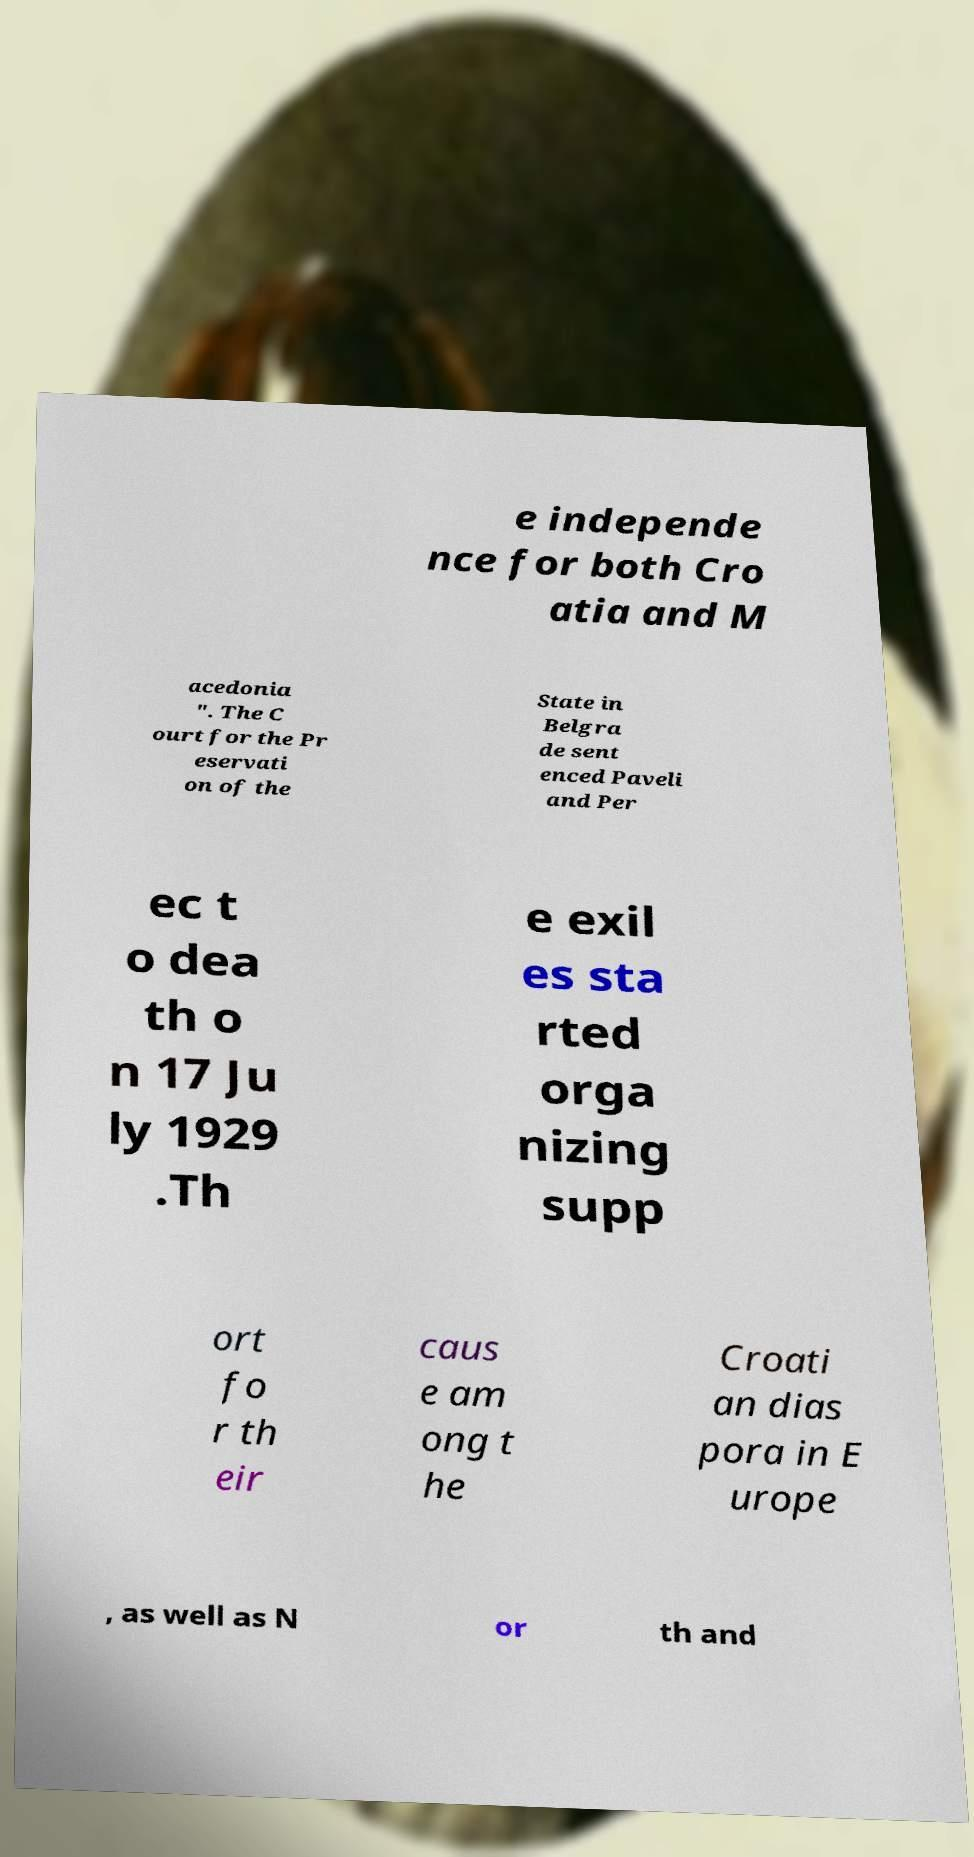Could you extract and type out the text from this image? e independe nce for both Cro atia and M acedonia ". The C ourt for the Pr eservati on of the State in Belgra de sent enced Paveli and Per ec t o dea th o n 17 Ju ly 1929 .Th e exil es sta rted orga nizing supp ort fo r th eir caus e am ong t he Croati an dias pora in E urope , as well as N or th and 